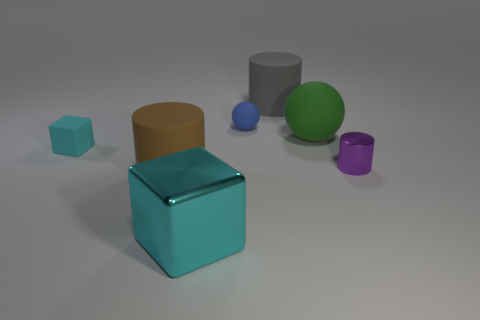Subtract all large cylinders. How many cylinders are left? 1 Subtract all green cylinders. Subtract all gray cubes. How many cylinders are left? 3 Add 2 tiny blue matte things. How many objects exist? 9 Subtract all cylinders. How many objects are left? 4 Subtract all small yellow metal cylinders. Subtract all large gray cylinders. How many objects are left? 6 Add 6 small metallic cylinders. How many small metallic cylinders are left? 7 Add 7 green matte spheres. How many green matte spheres exist? 8 Subtract 1 purple cylinders. How many objects are left? 6 